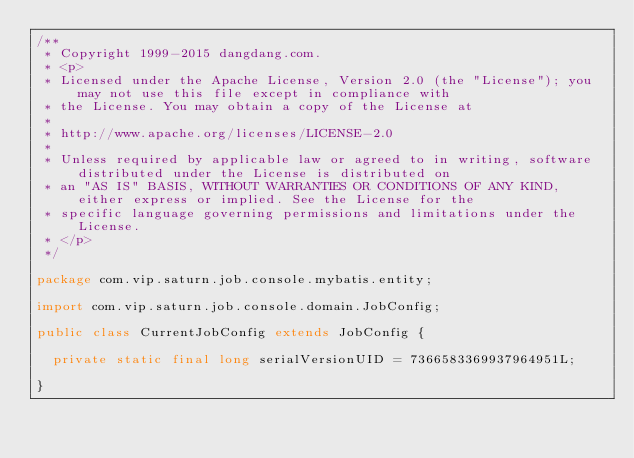<code> <loc_0><loc_0><loc_500><loc_500><_Java_>/**
 * Copyright 1999-2015 dangdang.com.
 * <p>
 * Licensed under the Apache License, Version 2.0 (the "License"); you may not use this file except in compliance with
 * the License. You may obtain a copy of the License at
 * 
 * http://www.apache.org/licenses/LICENSE-2.0
 * 
 * Unless required by applicable law or agreed to in writing, software distributed under the License is distributed on
 * an "AS IS" BASIS, WITHOUT WARRANTIES OR CONDITIONS OF ANY KIND, either express or implied. See the License for the
 * specific language governing permissions and limitations under the License.
 * </p>
 */

package com.vip.saturn.job.console.mybatis.entity;

import com.vip.saturn.job.console.domain.JobConfig;

public class CurrentJobConfig extends JobConfig {

	private static final long serialVersionUID = 7366583369937964951L;

}
</code> 